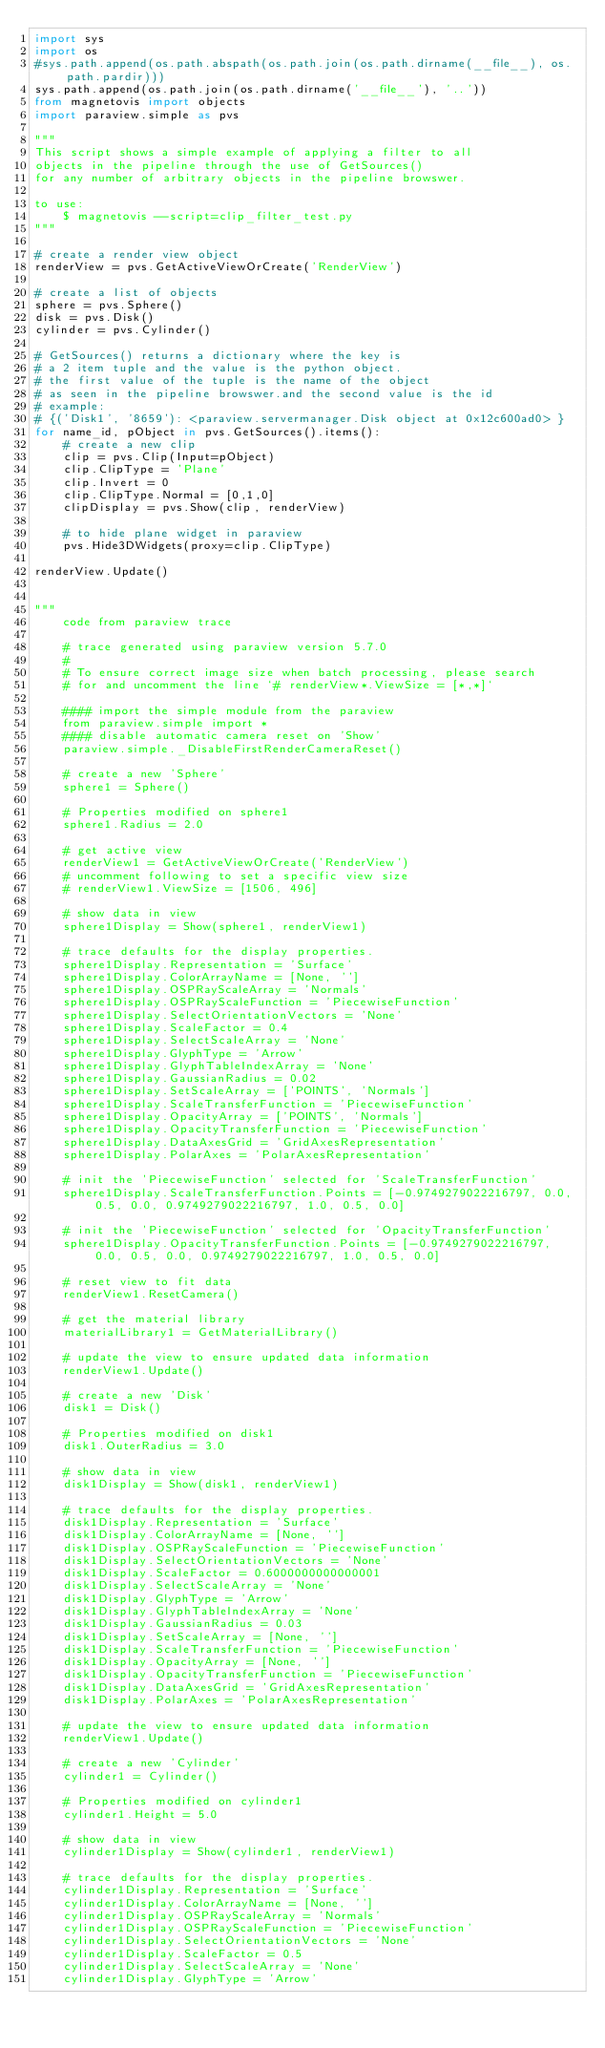<code> <loc_0><loc_0><loc_500><loc_500><_Python_>import sys
import os
#sys.path.append(os.path.abspath(os.path.join(os.path.dirname(__file__), os.path.pardir)))
sys.path.append(os.path.join(os.path.dirname('__file__'), '..'))
from magnetovis import objects
import paraview.simple as pvs

"""
This script shows a simple example of applying a filter to all
objects in the pipeline through the use of GetSources()
for any number of arbitrary objects in the pipeline browswer.

to use:
    $ magnetovis --script=clip_filter_test.py
"""

# create a render view object
renderView = pvs.GetActiveViewOrCreate('RenderView')

# create a list of objects
sphere = pvs.Sphere()
disk = pvs.Disk()
cylinder = pvs.Cylinder()

# GetSources() returns a dictionary where the key is
# a 2 item tuple and the value is the python object.
# the first value of the tuple is the name of the object
# as seen in the pipeline browswer.and the second value is the id
# example:
# {('Disk1', '8659'): <paraview.servermanager.Disk object at 0x12c600ad0> }
for name_id, pObject in pvs.GetSources().items():
    # create a new clip
    clip = pvs.Clip(Input=pObject)
    clip.ClipType = 'Plane'
    clip.Invert = 0
    clip.ClipType.Normal = [0,1,0]
    clipDisplay = pvs.Show(clip, renderView)
    
    # to hide plane widget in paraview
    pvs.Hide3DWidgets(proxy=clip.ClipType)

renderView.Update()


"""
    code from paraview trace
    
    # trace generated using paraview version 5.7.0
    #
    # To ensure correct image size when batch processing, please search
    # for and uncomment the line `# renderView*.ViewSize = [*,*]`

    #### import the simple module from the paraview
    from paraview.simple import *
    #### disable automatic camera reset on 'Show'
    paraview.simple._DisableFirstRenderCameraReset()

    # create a new 'Sphere'
    sphere1 = Sphere()

    # Properties modified on sphere1
    sphere1.Radius = 2.0

    # get active view
    renderView1 = GetActiveViewOrCreate('RenderView')
    # uncomment following to set a specific view size
    # renderView1.ViewSize = [1506, 496]

    # show data in view
    sphere1Display = Show(sphere1, renderView1)

    # trace defaults for the display properties.
    sphere1Display.Representation = 'Surface'
    sphere1Display.ColorArrayName = [None, '']
    sphere1Display.OSPRayScaleArray = 'Normals'
    sphere1Display.OSPRayScaleFunction = 'PiecewiseFunction'
    sphere1Display.SelectOrientationVectors = 'None'
    sphere1Display.ScaleFactor = 0.4
    sphere1Display.SelectScaleArray = 'None'
    sphere1Display.GlyphType = 'Arrow'
    sphere1Display.GlyphTableIndexArray = 'None'
    sphere1Display.GaussianRadius = 0.02
    sphere1Display.SetScaleArray = ['POINTS', 'Normals']
    sphere1Display.ScaleTransferFunction = 'PiecewiseFunction'
    sphere1Display.OpacityArray = ['POINTS', 'Normals']
    sphere1Display.OpacityTransferFunction = 'PiecewiseFunction'
    sphere1Display.DataAxesGrid = 'GridAxesRepresentation'
    sphere1Display.PolarAxes = 'PolarAxesRepresentation'

    # init the 'PiecewiseFunction' selected for 'ScaleTransferFunction'
    sphere1Display.ScaleTransferFunction.Points = [-0.9749279022216797, 0.0, 0.5, 0.0, 0.9749279022216797, 1.0, 0.5, 0.0]

    # init the 'PiecewiseFunction' selected for 'OpacityTransferFunction'
    sphere1Display.OpacityTransferFunction.Points = [-0.9749279022216797, 0.0, 0.5, 0.0, 0.9749279022216797, 1.0, 0.5, 0.0]

    # reset view to fit data
    renderView1.ResetCamera()

    # get the material library
    materialLibrary1 = GetMaterialLibrary()

    # update the view to ensure updated data information
    renderView1.Update()

    # create a new 'Disk'
    disk1 = Disk()

    # Properties modified on disk1
    disk1.OuterRadius = 3.0

    # show data in view
    disk1Display = Show(disk1, renderView1)

    # trace defaults for the display properties.
    disk1Display.Representation = 'Surface'
    disk1Display.ColorArrayName = [None, '']
    disk1Display.OSPRayScaleFunction = 'PiecewiseFunction'
    disk1Display.SelectOrientationVectors = 'None'
    disk1Display.ScaleFactor = 0.6000000000000001
    disk1Display.SelectScaleArray = 'None'
    disk1Display.GlyphType = 'Arrow'
    disk1Display.GlyphTableIndexArray = 'None'
    disk1Display.GaussianRadius = 0.03
    disk1Display.SetScaleArray = [None, '']
    disk1Display.ScaleTransferFunction = 'PiecewiseFunction'
    disk1Display.OpacityArray = [None, '']
    disk1Display.OpacityTransferFunction = 'PiecewiseFunction'
    disk1Display.DataAxesGrid = 'GridAxesRepresentation'
    disk1Display.PolarAxes = 'PolarAxesRepresentation'

    # update the view to ensure updated data information
    renderView1.Update()

    # create a new 'Cylinder'
    cylinder1 = Cylinder()

    # Properties modified on cylinder1
    cylinder1.Height = 5.0

    # show data in view
    cylinder1Display = Show(cylinder1, renderView1)

    # trace defaults for the display properties.
    cylinder1Display.Representation = 'Surface'
    cylinder1Display.ColorArrayName = [None, '']
    cylinder1Display.OSPRayScaleArray = 'Normals'
    cylinder1Display.OSPRayScaleFunction = 'PiecewiseFunction'
    cylinder1Display.SelectOrientationVectors = 'None'
    cylinder1Display.ScaleFactor = 0.5
    cylinder1Display.SelectScaleArray = 'None'
    cylinder1Display.GlyphType = 'Arrow'</code> 